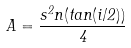Convert formula to latex. <formula><loc_0><loc_0><loc_500><loc_500>A = \frac { s ^ { 2 } n ( t a n ( i / 2 ) ) } { 4 }</formula> 